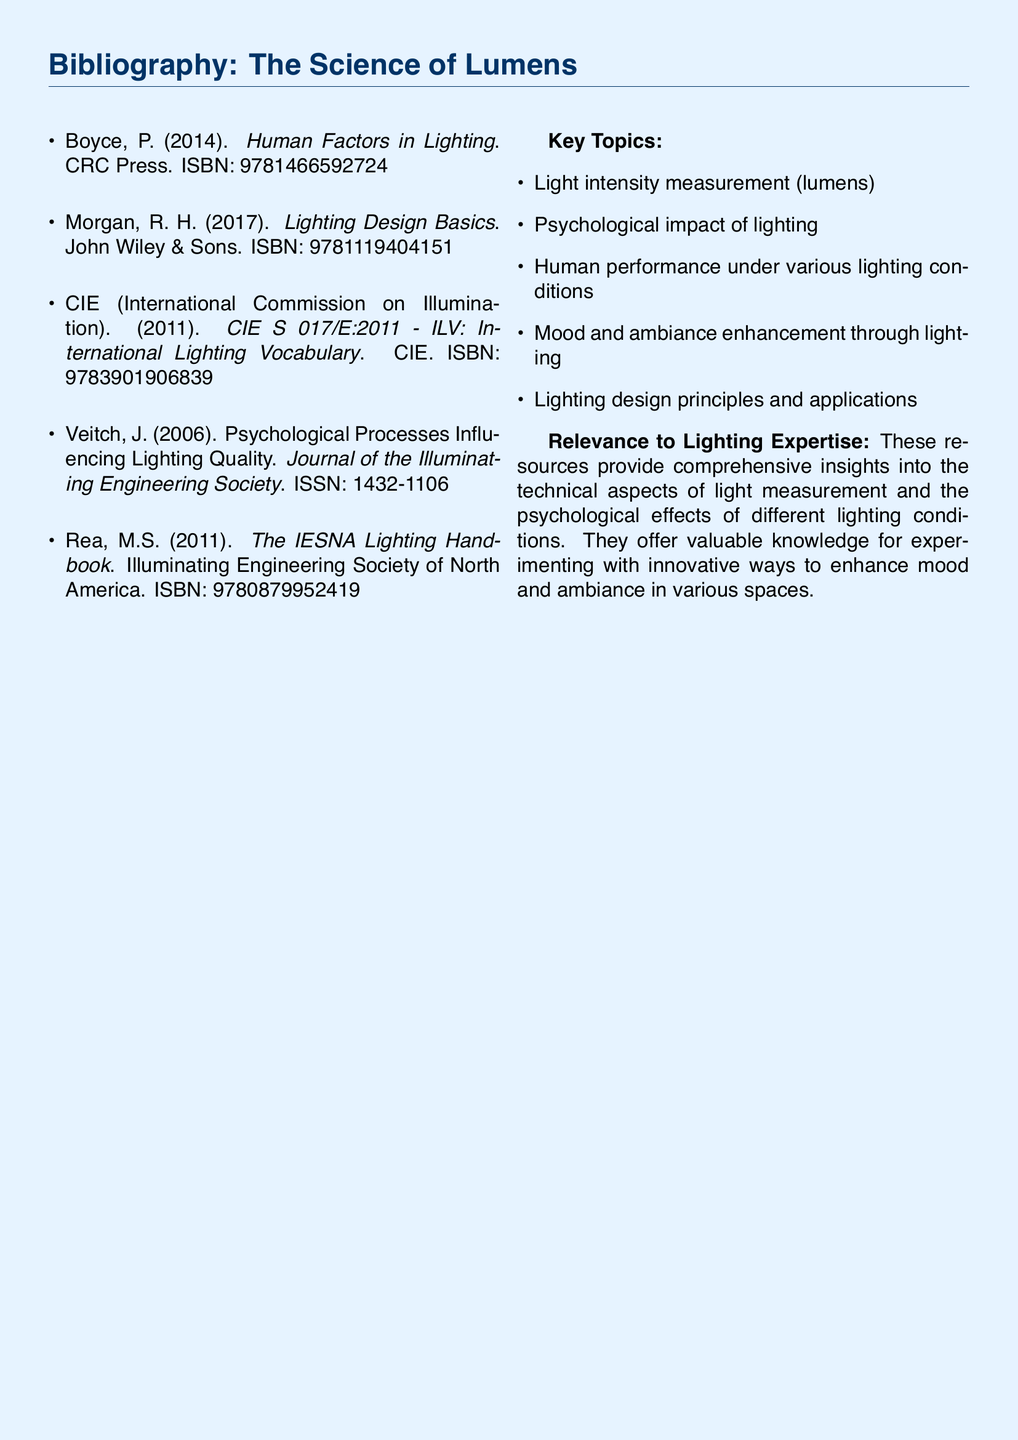What is the first resource listed in the bibliography? The first resource in the bibliography is always the one appearing at the top.
Answer: Human Factors in Lighting Who is the author of "Lighting Design Basics"? This is a title that includes the author's name directly after it.
Answer: R. H. Morgan What year was "CIE S 017/E:2011 - ILV: International Lighting Vocabulary" published? The year of publication can be found in parentheses next to the title.
Answer: 2011 How many key topics are listed in the document? The number of key topics can be counted in the specific section.
Answer: Five What is the main ISBN for "The IESNA Lighting Handbook"? The ISBN is presented as a unique identifier for each literary work.
Answer: 9780879952419 What is the main subject of the resource by Veitch, J.? This can be inferred from the title of the work itself.
Answer: Psychological Processes Influencing Lighting Quality Why are these resources relevant to lighting expertise? The relevance explanation summarizes the overall value and insights provided by the resources.
Answer: They provide comprehensive insights into technical aspects and psychological effects of lighting Which organization published the lighting vocabulary document? The publisher's name is mentioned in the reference information.
Answer: CIE 